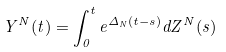<formula> <loc_0><loc_0><loc_500><loc_500>Y ^ { N } ( t ) = \int _ { 0 } ^ { t } e ^ { \Delta _ { N } ( t - s ) } d Z ^ { N } ( s )</formula> 